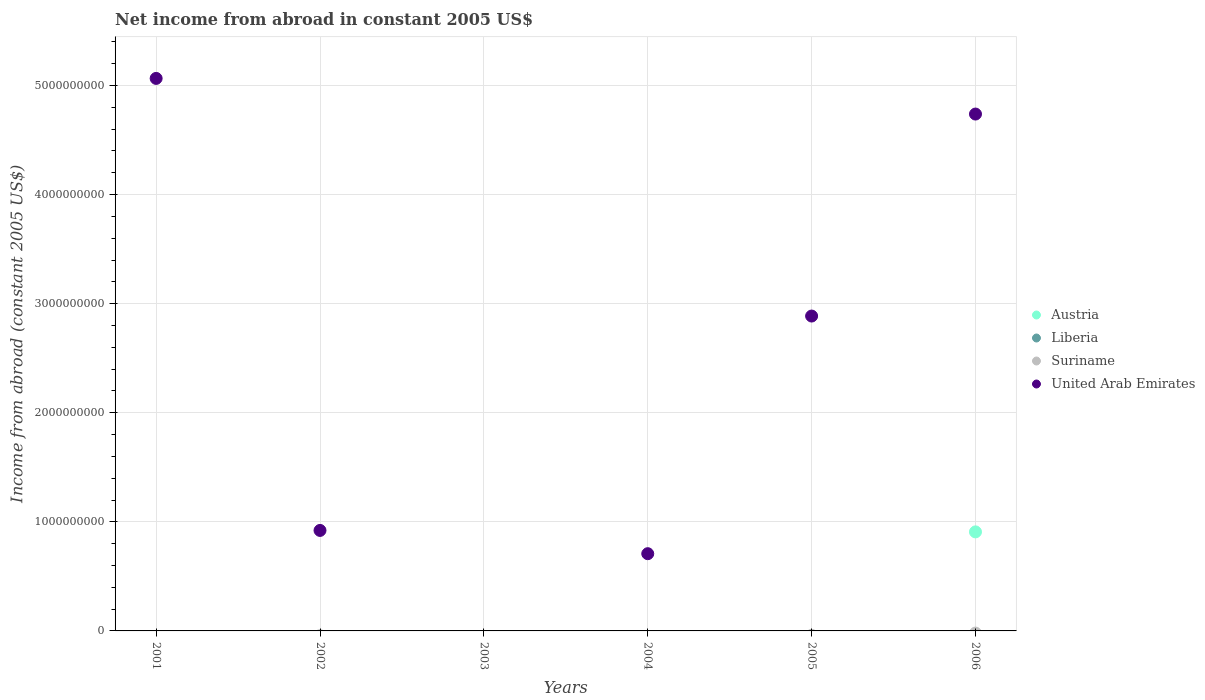What is the net income from abroad in United Arab Emirates in 2004?
Make the answer very short. 7.08e+08. Across all years, what is the maximum net income from abroad in Austria?
Your answer should be compact. 9.08e+08. Across all years, what is the minimum net income from abroad in United Arab Emirates?
Make the answer very short. 0. What is the difference between the net income from abroad in United Arab Emirates in 2002 and that in 2004?
Offer a very short reply. 2.13e+08. What is the average net income from abroad in United Arab Emirates per year?
Give a very brief answer. 2.39e+09. Is the net income from abroad in United Arab Emirates in 2002 less than that in 2004?
Your answer should be very brief. No. What is the difference between the highest and the second highest net income from abroad in United Arab Emirates?
Your answer should be compact. 3.27e+08. What is the difference between the highest and the lowest net income from abroad in Austria?
Provide a short and direct response. 9.08e+08. In how many years, is the net income from abroad in United Arab Emirates greater than the average net income from abroad in United Arab Emirates taken over all years?
Your answer should be very brief. 3. Is it the case that in every year, the sum of the net income from abroad in Liberia and net income from abroad in United Arab Emirates  is greater than the sum of net income from abroad in Suriname and net income from abroad in Austria?
Your answer should be very brief. No. Does the net income from abroad in Liberia monotonically increase over the years?
Your response must be concise. No. Is the net income from abroad in Suriname strictly greater than the net income from abroad in United Arab Emirates over the years?
Make the answer very short. No. Is the net income from abroad in Suriname strictly less than the net income from abroad in Austria over the years?
Your answer should be very brief. No. What is the difference between two consecutive major ticks on the Y-axis?
Give a very brief answer. 1.00e+09. Does the graph contain any zero values?
Give a very brief answer. Yes. How many legend labels are there?
Make the answer very short. 4. How are the legend labels stacked?
Offer a terse response. Vertical. What is the title of the graph?
Give a very brief answer. Net income from abroad in constant 2005 US$. What is the label or title of the X-axis?
Your answer should be very brief. Years. What is the label or title of the Y-axis?
Ensure brevity in your answer.  Income from abroad (constant 2005 US$). What is the Income from abroad (constant 2005 US$) in Suriname in 2001?
Provide a succinct answer. 0. What is the Income from abroad (constant 2005 US$) of United Arab Emirates in 2001?
Your answer should be very brief. 5.06e+09. What is the Income from abroad (constant 2005 US$) of Liberia in 2002?
Ensure brevity in your answer.  0. What is the Income from abroad (constant 2005 US$) in United Arab Emirates in 2002?
Ensure brevity in your answer.  9.21e+08. What is the Income from abroad (constant 2005 US$) in Liberia in 2003?
Your answer should be compact. 0. What is the Income from abroad (constant 2005 US$) in United Arab Emirates in 2003?
Keep it short and to the point. 0. What is the Income from abroad (constant 2005 US$) in Suriname in 2004?
Your answer should be very brief. 0. What is the Income from abroad (constant 2005 US$) in United Arab Emirates in 2004?
Offer a terse response. 7.08e+08. What is the Income from abroad (constant 2005 US$) of Austria in 2005?
Offer a terse response. 0. What is the Income from abroad (constant 2005 US$) in Liberia in 2005?
Your response must be concise. 0. What is the Income from abroad (constant 2005 US$) in United Arab Emirates in 2005?
Provide a succinct answer. 2.89e+09. What is the Income from abroad (constant 2005 US$) of Austria in 2006?
Make the answer very short. 9.08e+08. What is the Income from abroad (constant 2005 US$) of United Arab Emirates in 2006?
Make the answer very short. 4.74e+09. Across all years, what is the maximum Income from abroad (constant 2005 US$) in Austria?
Keep it short and to the point. 9.08e+08. Across all years, what is the maximum Income from abroad (constant 2005 US$) in United Arab Emirates?
Your response must be concise. 5.06e+09. Across all years, what is the minimum Income from abroad (constant 2005 US$) in Austria?
Your response must be concise. 0. What is the total Income from abroad (constant 2005 US$) of Austria in the graph?
Offer a terse response. 9.08e+08. What is the total Income from abroad (constant 2005 US$) of United Arab Emirates in the graph?
Your answer should be very brief. 1.43e+1. What is the difference between the Income from abroad (constant 2005 US$) in United Arab Emirates in 2001 and that in 2002?
Offer a very short reply. 4.14e+09. What is the difference between the Income from abroad (constant 2005 US$) in United Arab Emirates in 2001 and that in 2004?
Make the answer very short. 4.36e+09. What is the difference between the Income from abroad (constant 2005 US$) of United Arab Emirates in 2001 and that in 2005?
Provide a succinct answer. 2.18e+09. What is the difference between the Income from abroad (constant 2005 US$) of United Arab Emirates in 2001 and that in 2006?
Keep it short and to the point. 3.27e+08. What is the difference between the Income from abroad (constant 2005 US$) of United Arab Emirates in 2002 and that in 2004?
Ensure brevity in your answer.  2.13e+08. What is the difference between the Income from abroad (constant 2005 US$) in United Arab Emirates in 2002 and that in 2005?
Keep it short and to the point. -1.97e+09. What is the difference between the Income from abroad (constant 2005 US$) of United Arab Emirates in 2002 and that in 2006?
Make the answer very short. -3.82e+09. What is the difference between the Income from abroad (constant 2005 US$) of United Arab Emirates in 2004 and that in 2005?
Provide a succinct answer. -2.18e+09. What is the difference between the Income from abroad (constant 2005 US$) in United Arab Emirates in 2004 and that in 2006?
Your answer should be compact. -4.03e+09. What is the difference between the Income from abroad (constant 2005 US$) in United Arab Emirates in 2005 and that in 2006?
Your response must be concise. -1.85e+09. What is the average Income from abroad (constant 2005 US$) in Austria per year?
Keep it short and to the point. 1.51e+08. What is the average Income from abroad (constant 2005 US$) in Suriname per year?
Offer a very short reply. 0. What is the average Income from abroad (constant 2005 US$) of United Arab Emirates per year?
Ensure brevity in your answer.  2.39e+09. In the year 2006, what is the difference between the Income from abroad (constant 2005 US$) of Austria and Income from abroad (constant 2005 US$) of United Arab Emirates?
Your answer should be compact. -3.83e+09. What is the ratio of the Income from abroad (constant 2005 US$) in United Arab Emirates in 2001 to that in 2002?
Keep it short and to the point. 5.5. What is the ratio of the Income from abroad (constant 2005 US$) in United Arab Emirates in 2001 to that in 2004?
Provide a short and direct response. 7.15. What is the ratio of the Income from abroad (constant 2005 US$) in United Arab Emirates in 2001 to that in 2005?
Give a very brief answer. 1.75. What is the ratio of the Income from abroad (constant 2005 US$) in United Arab Emirates in 2001 to that in 2006?
Ensure brevity in your answer.  1.07. What is the ratio of the Income from abroad (constant 2005 US$) of United Arab Emirates in 2002 to that in 2004?
Keep it short and to the point. 1.3. What is the ratio of the Income from abroad (constant 2005 US$) in United Arab Emirates in 2002 to that in 2005?
Offer a very short reply. 0.32. What is the ratio of the Income from abroad (constant 2005 US$) in United Arab Emirates in 2002 to that in 2006?
Make the answer very short. 0.19. What is the ratio of the Income from abroad (constant 2005 US$) of United Arab Emirates in 2004 to that in 2005?
Offer a very short reply. 0.25. What is the ratio of the Income from abroad (constant 2005 US$) in United Arab Emirates in 2004 to that in 2006?
Your answer should be very brief. 0.15. What is the ratio of the Income from abroad (constant 2005 US$) of United Arab Emirates in 2005 to that in 2006?
Offer a very short reply. 0.61. What is the difference between the highest and the second highest Income from abroad (constant 2005 US$) in United Arab Emirates?
Ensure brevity in your answer.  3.27e+08. What is the difference between the highest and the lowest Income from abroad (constant 2005 US$) in Austria?
Give a very brief answer. 9.08e+08. What is the difference between the highest and the lowest Income from abroad (constant 2005 US$) of United Arab Emirates?
Your answer should be very brief. 5.06e+09. 